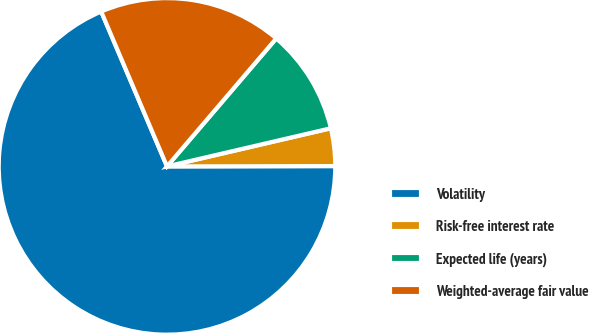Convert chart to OTSL. <chart><loc_0><loc_0><loc_500><loc_500><pie_chart><fcel>Volatility<fcel>Risk-free interest rate<fcel>Expected life (years)<fcel>Weighted-average fair value<nl><fcel>68.63%<fcel>3.61%<fcel>10.11%<fcel>17.64%<nl></chart> 